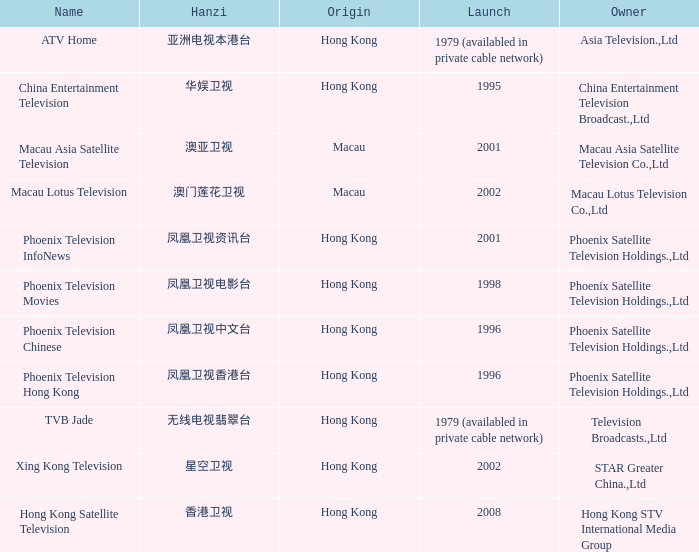What is the hanzi representation of phoenix television chinese that began in 1996? 凤凰卫视中文台. 